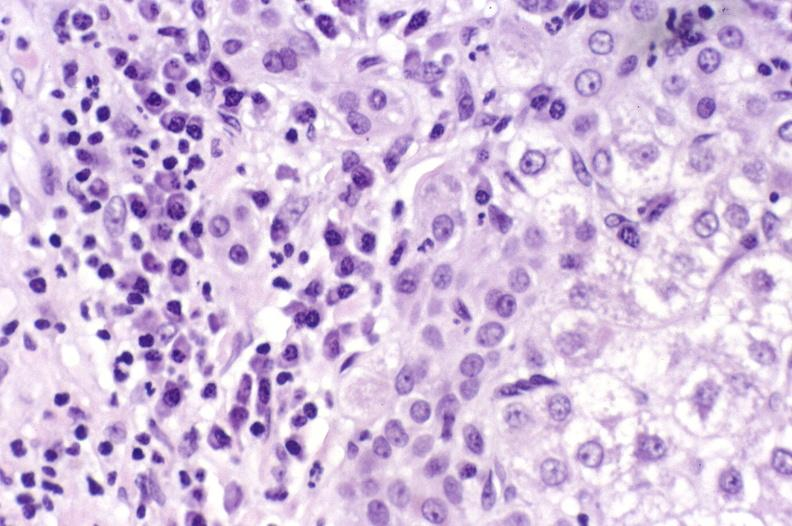s hepatobiliary present?
Answer the question using a single word or phrase. Yes 